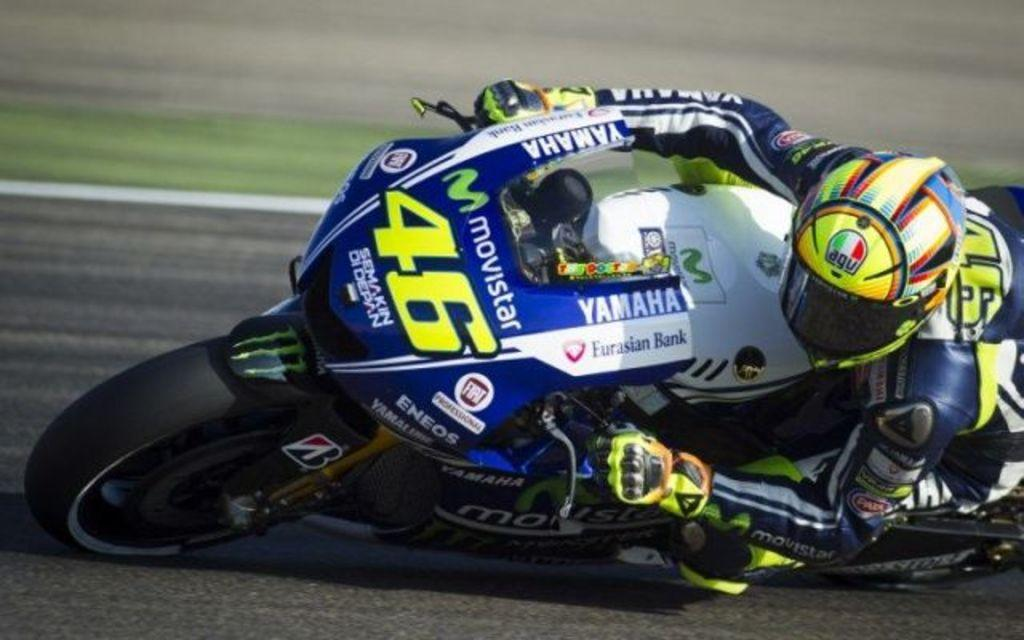What is the main subject of the image? The main subject of the image is a man. What is the man doing in the image? The man is riding a bike in the image. Are there any additional details on the bike? Yes, there are texts written on the bike. How would you describe the background of the image? The background of the image is blurry. What type of meal is the man eating while riding the bike in the image? There is no meal present in the image; the man is riding a bike with texts written on it. Can you see any ghosts in the image? There are no ghosts present in the image; it features a man riding a bike with texts written on it and a blurry background. 